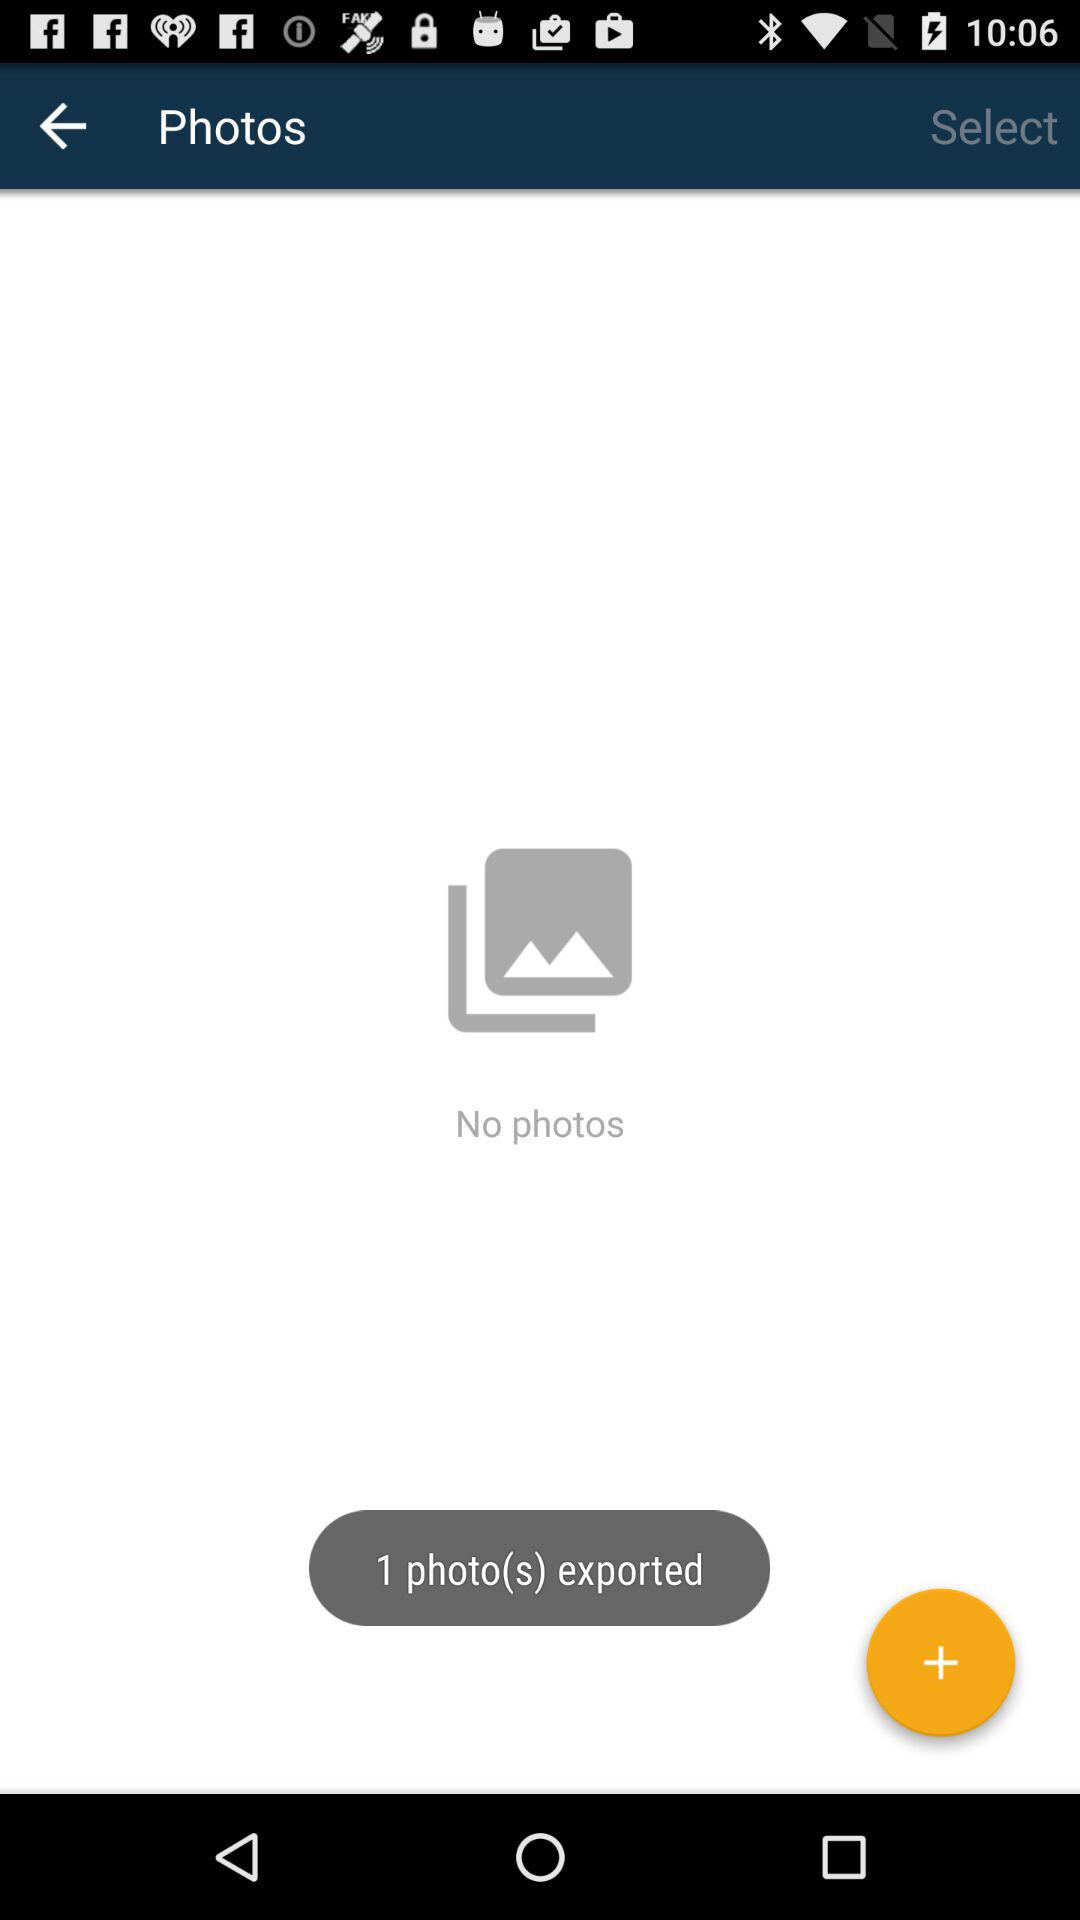Which photo was selected?
When the provided information is insufficient, respond with <no answer>. <no answer> 